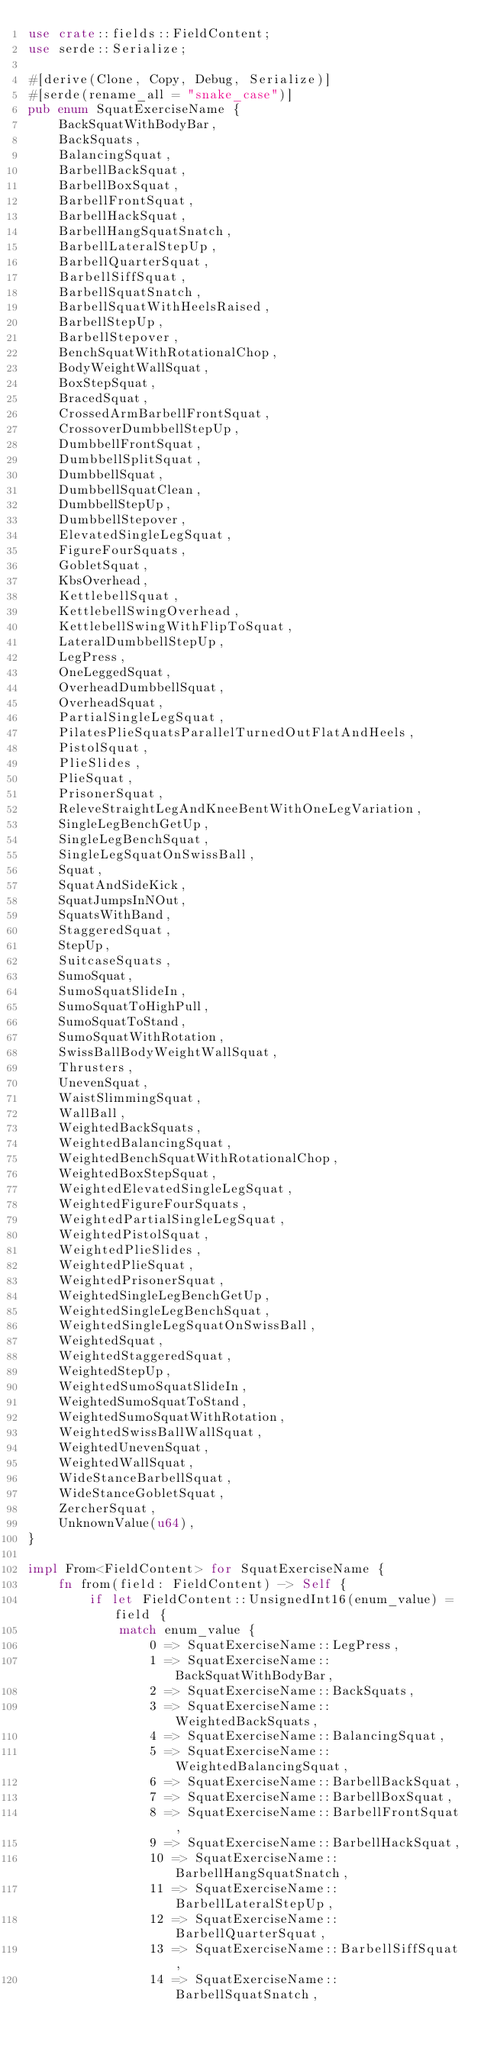Convert code to text. <code><loc_0><loc_0><loc_500><loc_500><_Rust_>use crate::fields::FieldContent;
use serde::Serialize;

#[derive(Clone, Copy, Debug, Serialize)]
#[serde(rename_all = "snake_case")]
pub enum SquatExerciseName {
    BackSquatWithBodyBar,
    BackSquats,
    BalancingSquat,
    BarbellBackSquat,
    BarbellBoxSquat,
    BarbellFrontSquat,
    BarbellHackSquat,
    BarbellHangSquatSnatch,
    BarbellLateralStepUp,
    BarbellQuarterSquat,
    BarbellSiffSquat,
    BarbellSquatSnatch,
    BarbellSquatWithHeelsRaised,
    BarbellStepUp,
    BarbellStepover,
    BenchSquatWithRotationalChop,
    BodyWeightWallSquat,
    BoxStepSquat,
    BracedSquat,
    CrossedArmBarbellFrontSquat,
    CrossoverDumbbellStepUp,
    DumbbellFrontSquat,
    DumbbellSplitSquat,
    DumbbellSquat,
    DumbbellSquatClean,
    DumbbellStepUp,
    DumbbellStepover,
    ElevatedSingleLegSquat,
    FigureFourSquats,
    GobletSquat,
    KbsOverhead,
    KettlebellSquat,
    KettlebellSwingOverhead,
    KettlebellSwingWithFlipToSquat,
    LateralDumbbellStepUp,
    LegPress,
    OneLeggedSquat,
    OverheadDumbbellSquat,
    OverheadSquat,
    PartialSingleLegSquat,
    PilatesPlieSquatsParallelTurnedOutFlatAndHeels,
    PistolSquat,
    PlieSlides,
    PlieSquat,
    PrisonerSquat,
    ReleveStraightLegAndKneeBentWithOneLegVariation,
    SingleLegBenchGetUp,
    SingleLegBenchSquat,
    SingleLegSquatOnSwissBall,
    Squat,
    SquatAndSideKick,
    SquatJumpsInNOut,
    SquatsWithBand,
    StaggeredSquat,
    StepUp,
    SuitcaseSquats,
    SumoSquat,
    SumoSquatSlideIn,
    SumoSquatToHighPull,
    SumoSquatToStand,
    SumoSquatWithRotation,
    SwissBallBodyWeightWallSquat,
    Thrusters,
    UnevenSquat,
    WaistSlimmingSquat,
    WallBall,
    WeightedBackSquats,
    WeightedBalancingSquat,
    WeightedBenchSquatWithRotationalChop,
    WeightedBoxStepSquat,
    WeightedElevatedSingleLegSquat,
    WeightedFigureFourSquats,
    WeightedPartialSingleLegSquat,
    WeightedPistolSquat,
    WeightedPlieSlides,
    WeightedPlieSquat,
    WeightedPrisonerSquat,
    WeightedSingleLegBenchGetUp,
    WeightedSingleLegBenchSquat,
    WeightedSingleLegSquatOnSwissBall,
    WeightedSquat,
    WeightedStaggeredSquat,
    WeightedStepUp,
    WeightedSumoSquatSlideIn,
    WeightedSumoSquatToStand,
    WeightedSumoSquatWithRotation,
    WeightedSwissBallWallSquat,
    WeightedUnevenSquat,
    WeightedWallSquat,
    WideStanceBarbellSquat,
    WideStanceGobletSquat,
    ZercherSquat,
    UnknownValue(u64),
}

impl From<FieldContent> for SquatExerciseName {
    fn from(field: FieldContent) -> Self {
        if let FieldContent::UnsignedInt16(enum_value) = field {
            match enum_value {
                0 => SquatExerciseName::LegPress,
                1 => SquatExerciseName::BackSquatWithBodyBar,
                2 => SquatExerciseName::BackSquats,
                3 => SquatExerciseName::WeightedBackSquats,
                4 => SquatExerciseName::BalancingSquat,
                5 => SquatExerciseName::WeightedBalancingSquat,
                6 => SquatExerciseName::BarbellBackSquat,
                7 => SquatExerciseName::BarbellBoxSquat,
                8 => SquatExerciseName::BarbellFrontSquat,
                9 => SquatExerciseName::BarbellHackSquat,
                10 => SquatExerciseName::BarbellHangSquatSnatch,
                11 => SquatExerciseName::BarbellLateralStepUp,
                12 => SquatExerciseName::BarbellQuarterSquat,
                13 => SquatExerciseName::BarbellSiffSquat,
                14 => SquatExerciseName::BarbellSquatSnatch,</code> 